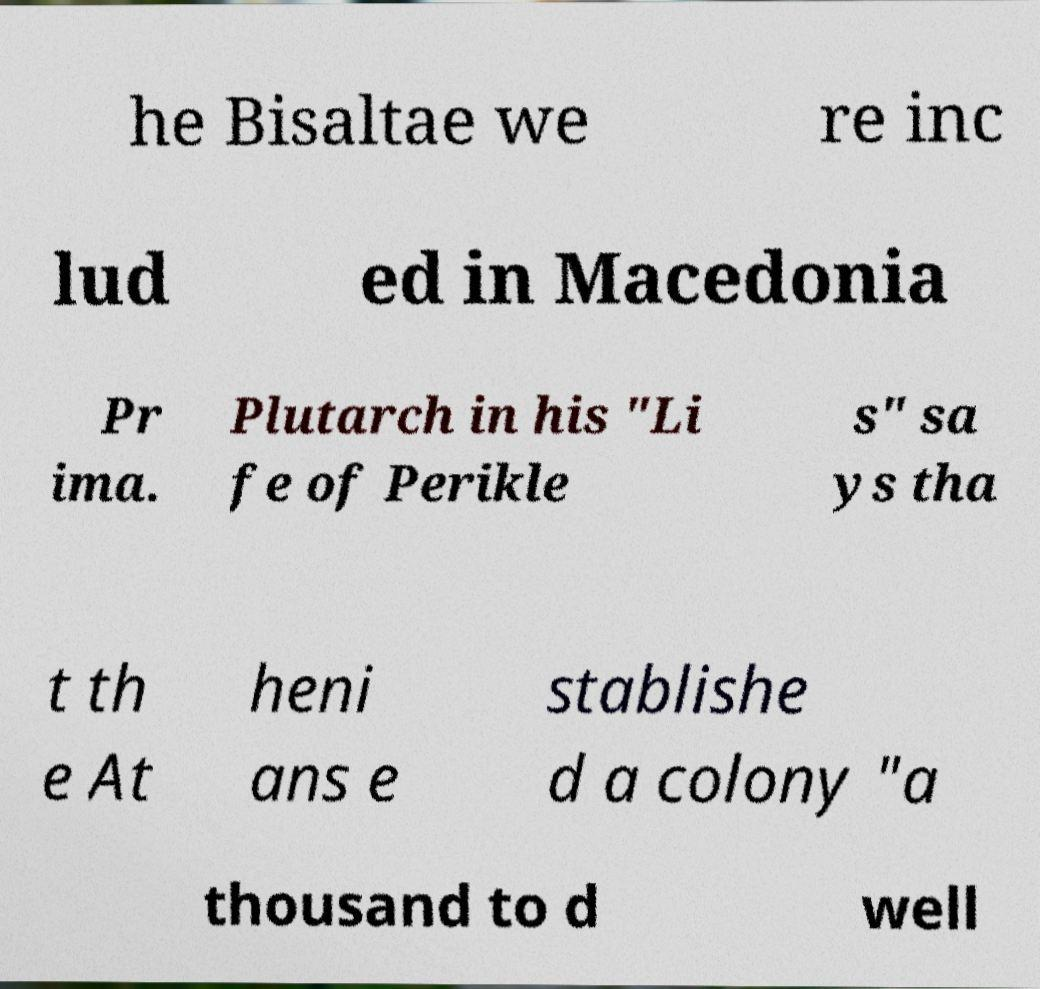I need the written content from this picture converted into text. Can you do that? he Bisaltae we re inc lud ed in Macedonia Pr ima. Plutarch in his "Li fe of Perikle s" sa ys tha t th e At heni ans e stablishe d a colony "a thousand to d well 